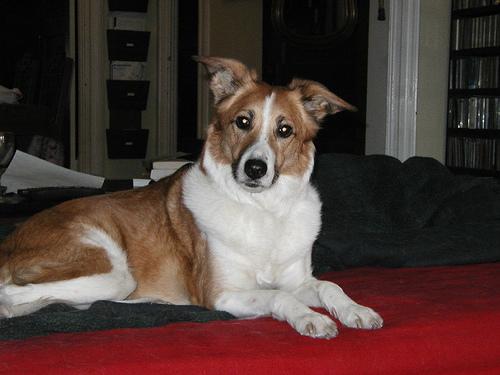Do you see a white flower pot?
Answer briefly. No. Does the dog have a collar?
Answer briefly. No. What color fur does this dog have?
Concise answer only. Brown and white. Is the blanket yellow?
Concise answer only. No. Why type of dog is this?
Concise answer only. Collie. 